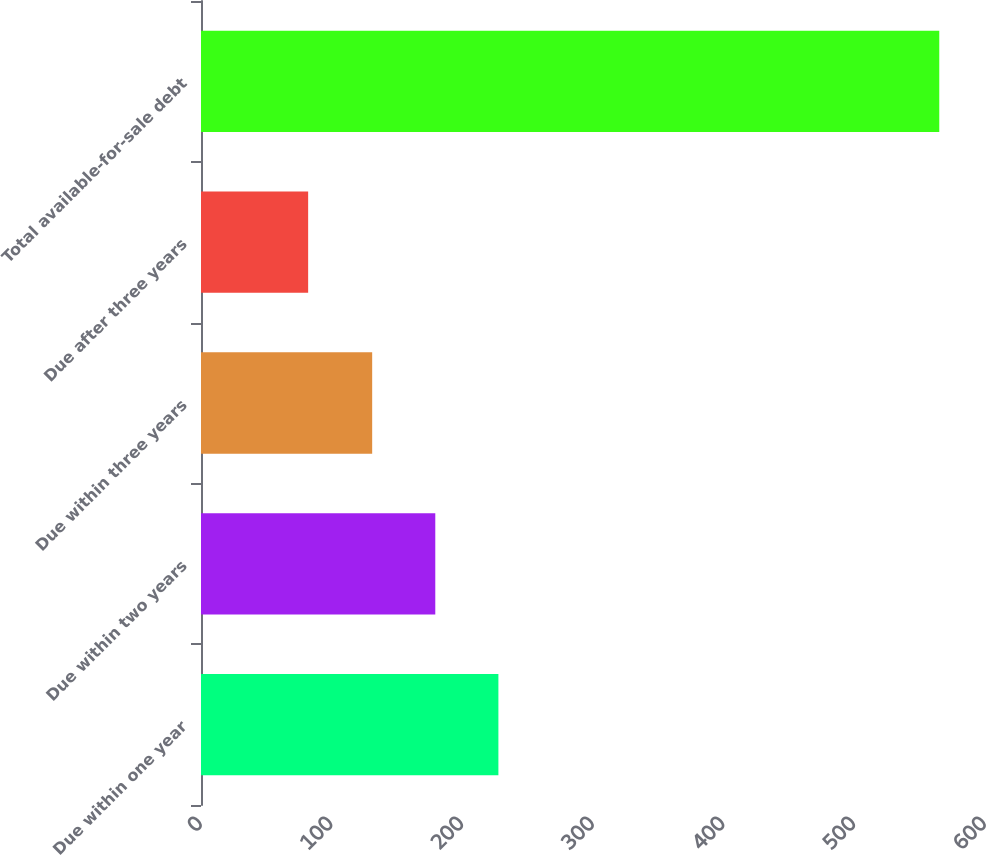Convert chart to OTSL. <chart><loc_0><loc_0><loc_500><loc_500><bar_chart><fcel>Due within one year<fcel>Due within two years<fcel>Due within three years<fcel>Due after three years<fcel>Total available-for-sale debt<nl><fcel>227.6<fcel>179.3<fcel>131<fcel>82<fcel>565<nl></chart> 